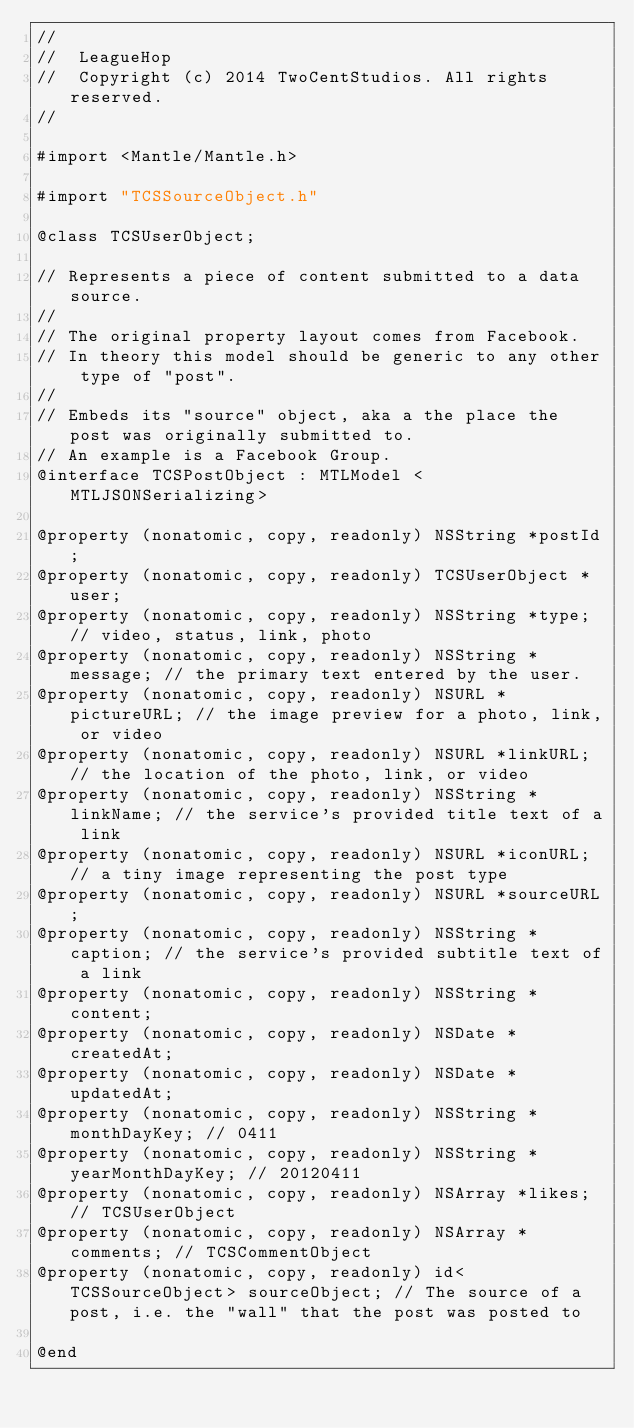<code> <loc_0><loc_0><loc_500><loc_500><_C_>//
//  LeagueHop
//  Copyright (c) 2014 TwoCentStudios. All rights reserved.
//

#import <Mantle/Mantle.h>

#import "TCSSourceObject.h"

@class TCSUserObject;

// Represents a piece of content submitted to a data source.
//
// The original property layout comes from Facebook.
// In theory this model should be generic to any other type of "post".
//
// Embeds its "source" object, aka a the place the post was originally submitted to.
// An example is a Facebook Group.
@interface TCSPostObject : MTLModel <MTLJSONSerializing>

@property (nonatomic, copy, readonly) NSString *postId;
@property (nonatomic, copy, readonly) TCSUserObject *user;
@property (nonatomic, copy, readonly) NSString *type; // video, status, link, photo
@property (nonatomic, copy, readonly) NSString *message; // the primary text entered by the user.
@property (nonatomic, copy, readonly) NSURL *pictureURL; // the image preview for a photo, link, or video
@property (nonatomic, copy, readonly) NSURL *linkURL; // the location of the photo, link, or video
@property (nonatomic, copy, readonly) NSString *linkName; // the service's provided title text of a link
@property (nonatomic, copy, readonly) NSURL *iconURL; // a tiny image representing the post type
@property (nonatomic, copy, readonly) NSURL *sourceURL; 
@property (nonatomic, copy, readonly) NSString *caption; // the service's provided subtitle text of a link
@property (nonatomic, copy, readonly) NSString *content;
@property (nonatomic, copy, readonly) NSDate *createdAt;
@property (nonatomic, copy, readonly) NSDate *updatedAt;
@property (nonatomic, copy, readonly) NSString *monthDayKey; // 0411
@property (nonatomic, copy, readonly) NSString *yearMonthDayKey; // 20120411
@property (nonatomic, copy, readonly) NSArray *likes; // TCSUserObject
@property (nonatomic, copy, readonly) NSArray *comments; // TCSCommentObject
@property (nonatomic, copy, readonly) id<TCSSourceObject> sourceObject; // The source of a post, i.e. the "wall" that the post was posted to

@end
</code> 